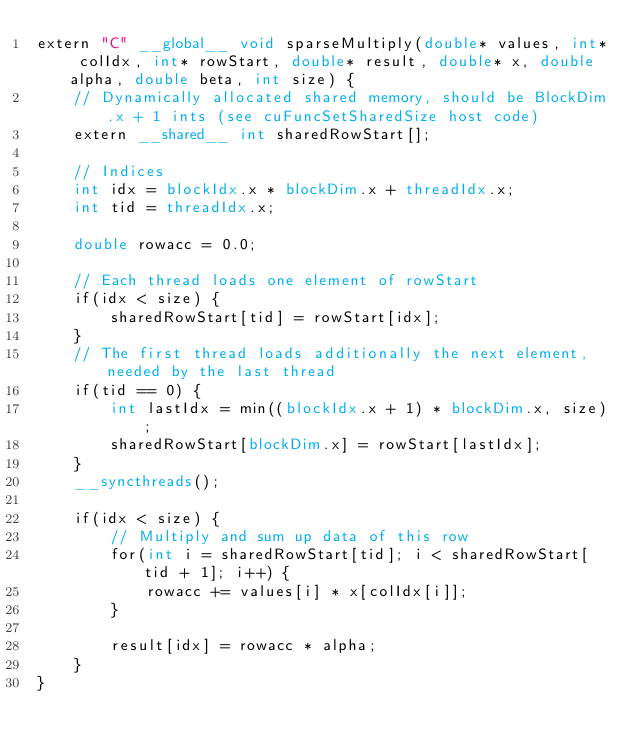<code> <loc_0><loc_0><loc_500><loc_500><_Cuda_>extern "C" __global__ void sparseMultiply(double* values, int* colIdx, int* rowStart, double* result, double* x, double alpha, double beta, int size) {
	// Dynamically allocated shared memory, should be BlockDim.x + 1 ints (see cuFuncSetSharedSize host code)
	extern __shared__ int sharedRowStart[];
	
	// Indices
	int idx = blockIdx.x * blockDim.x + threadIdx.x;
	int tid = threadIdx.x;
	
	double rowacc = 0.0;
	
	// Each thread loads one element of rowStart
	if(idx < size) {
		sharedRowStart[tid] = rowStart[idx];
	}
	// The first thread loads additionally the next element, needed by the last thread
	if(tid == 0) {
		int lastIdx = min((blockIdx.x + 1) * blockDim.x, size);
		sharedRowStart[blockDim.x] = rowStart[lastIdx];
	}
	__syncthreads();
	
	if(idx < size) {
		// Multiply and sum up data of this row
		for(int i = sharedRowStart[tid]; i < sharedRowStart[tid + 1]; i++) {
			rowacc += values[i] * x[colIdx[i]];
		}

		result[idx] = rowacc * alpha;
	}
}
</code> 